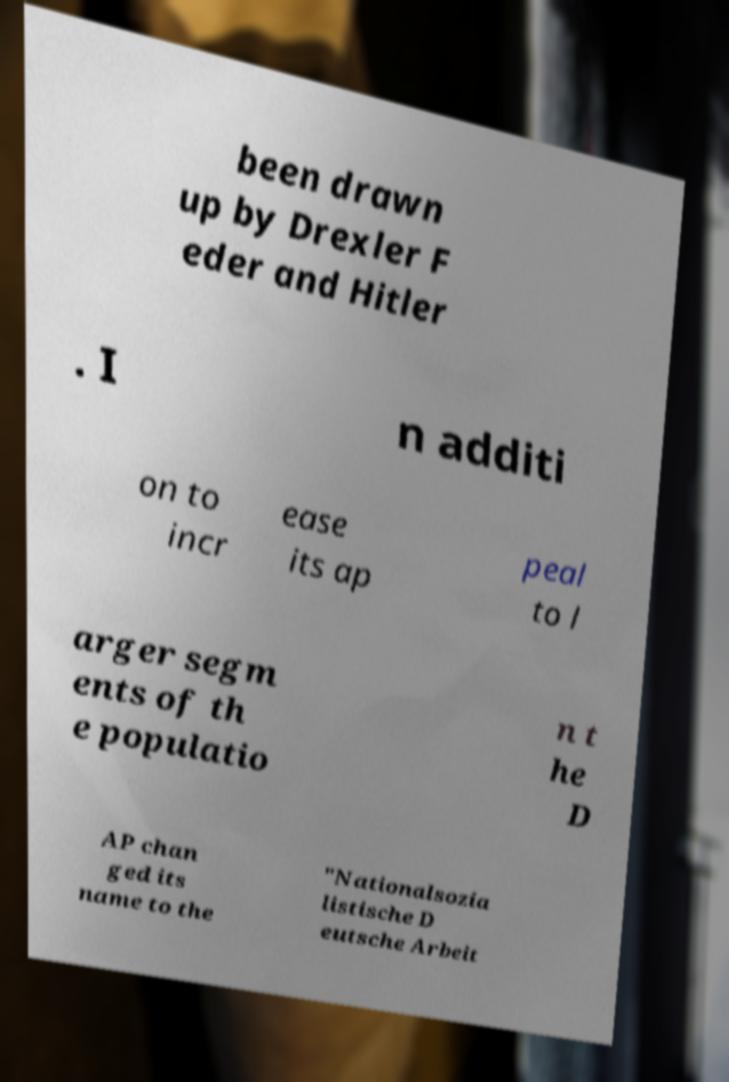Please read and relay the text visible in this image. What does it say? been drawn up by Drexler F eder and Hitler . I n additi on to incr ease its ap peal to l arger segm ents of th e populatio n t he D AP chan ged its name to the "Nationalsozia listische D eutsche Arbeit 